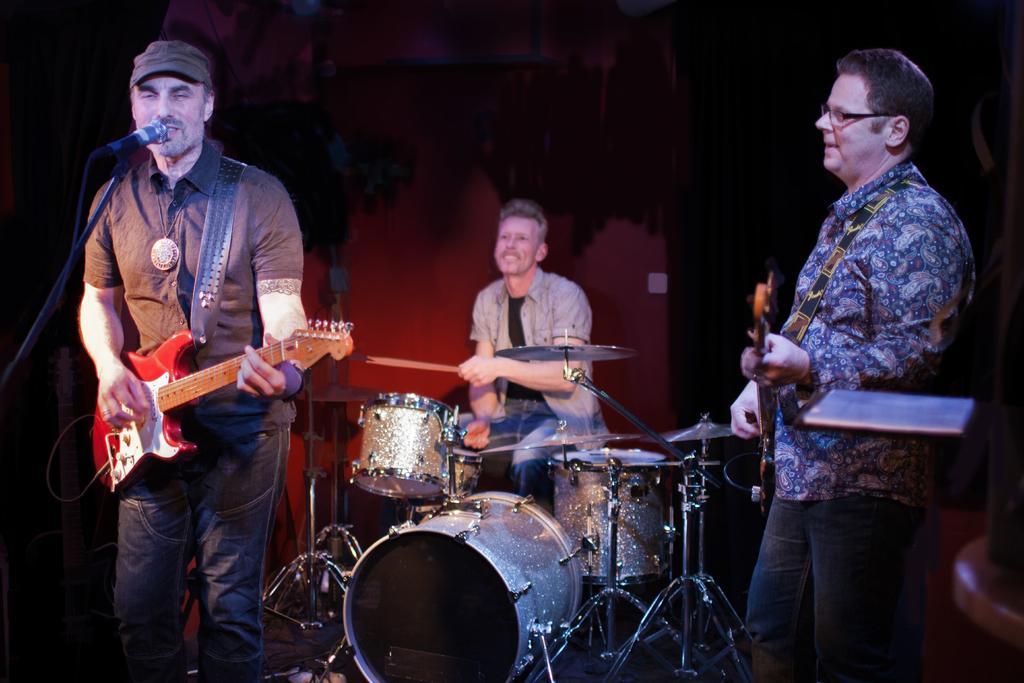Can you describe this image briefly? There are two men are standing and holding a music instruments and a man sitting on the chair is playing a music instrument and a man singing in the microphone. 